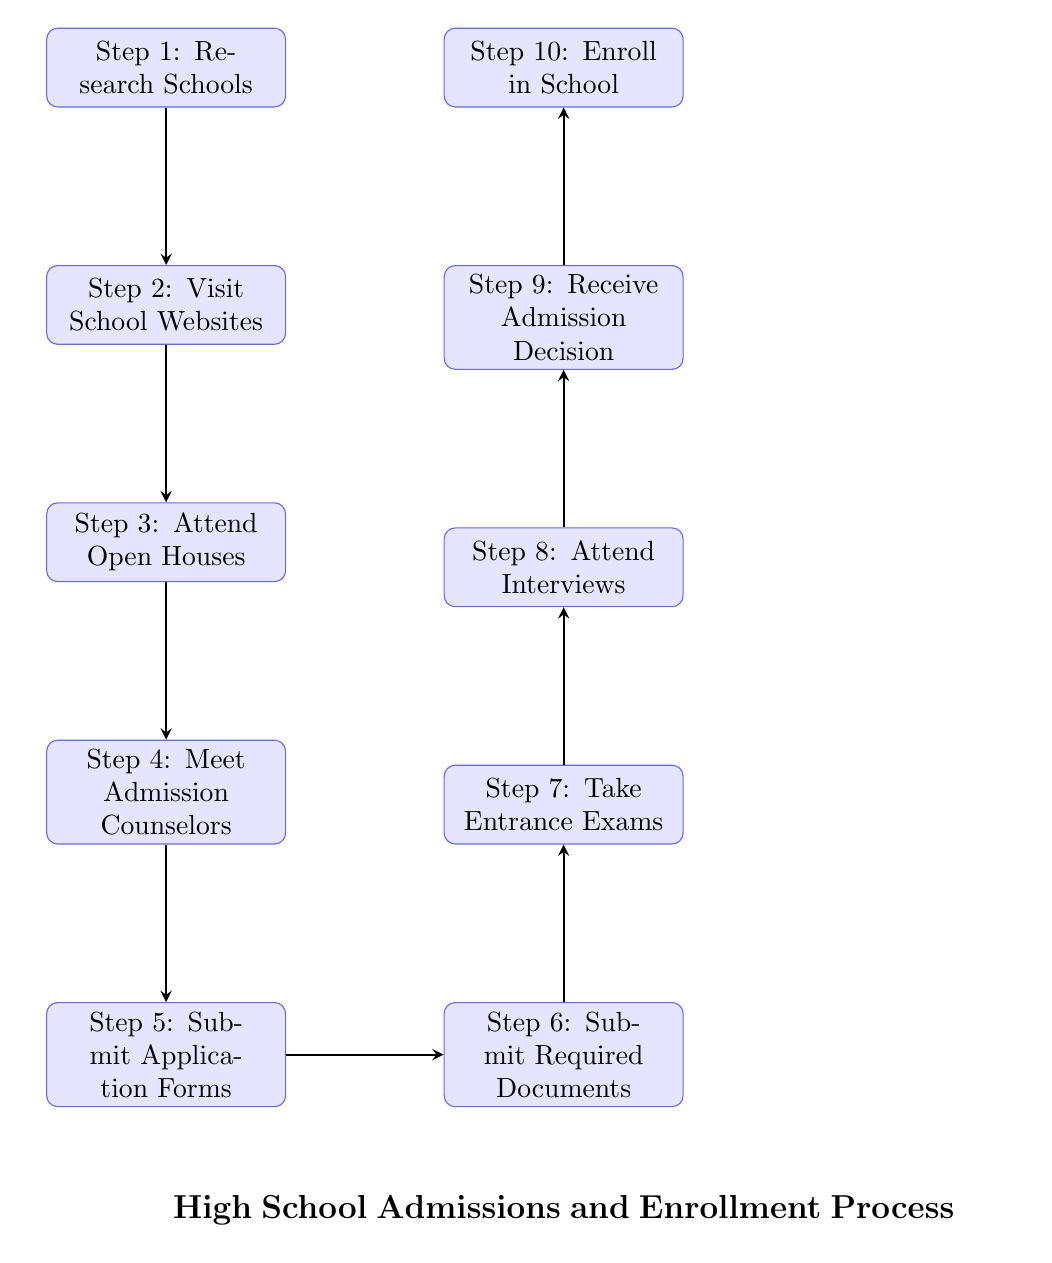What is the first step in the admissions process? The first step in the diagram is labeled as "Step 1: Research Schools", which indicates what needs to be done first.
Answer: Step 1: Research Schools How many steps are there in total for high school admissions? By counting the numbered steps provided in the diagram (from Step 1 to Step 10), there are a total of ten steps in the admissions and enrollment process.
Answer: 10 What is the sixth step in the process? The sixth step in the diagram is labeled as "Step 6: Submit Required Documents". This directly answers which step it is without needing to cross-reference other steps.
Answer: Step 6: Submit Required Documents What relationship exists between Step 5 and Step 6? The relationship between Step 5 ("Submit Application Forms") and Step 6 ("Submit Required Documents") is sequential; Step 5 must be completed before Step 6 can begin, as indicated by the arrow pointing from Step 5 to Step 6.
Answer: Sequential What is the last step before enrollment? The last step before enrollment in the process is "Step 9: Receive Admission Decision". This step is crucial as it determines if the application is successful before enrolling.
Answer: Step 9: Receive Admission Decision Which step involves meeting staff? The step that involves meeting staff is "Step 4: Meet Admission Counselors", as indicated in the flow of steps when meeting with those involved in the admissions process.
Answer: Step 4: Meet Admission Counselors What must be done before attending interviews? Before attending interviews (Step 8), the previous step (Step 7) requires taking entrance exams, thereby making it a prerequisite. This outlines the process order clearly.
Answer: Step 7: Take Entrance Exams What comes directly after attending open houses? Directly after attending open houses (Step 3), the next step is to meet admission counselors (Step 4), indicating a clear progression in the admissions process.
Answer: Step 4: Meet Admission Counselors Which step includes taking tests? The step that includes taking tests is "Step 7: Take Entrance Exams". This highlights an assessment activity within the admissions process.
Answer: Step 7: Take Entrance Exams 